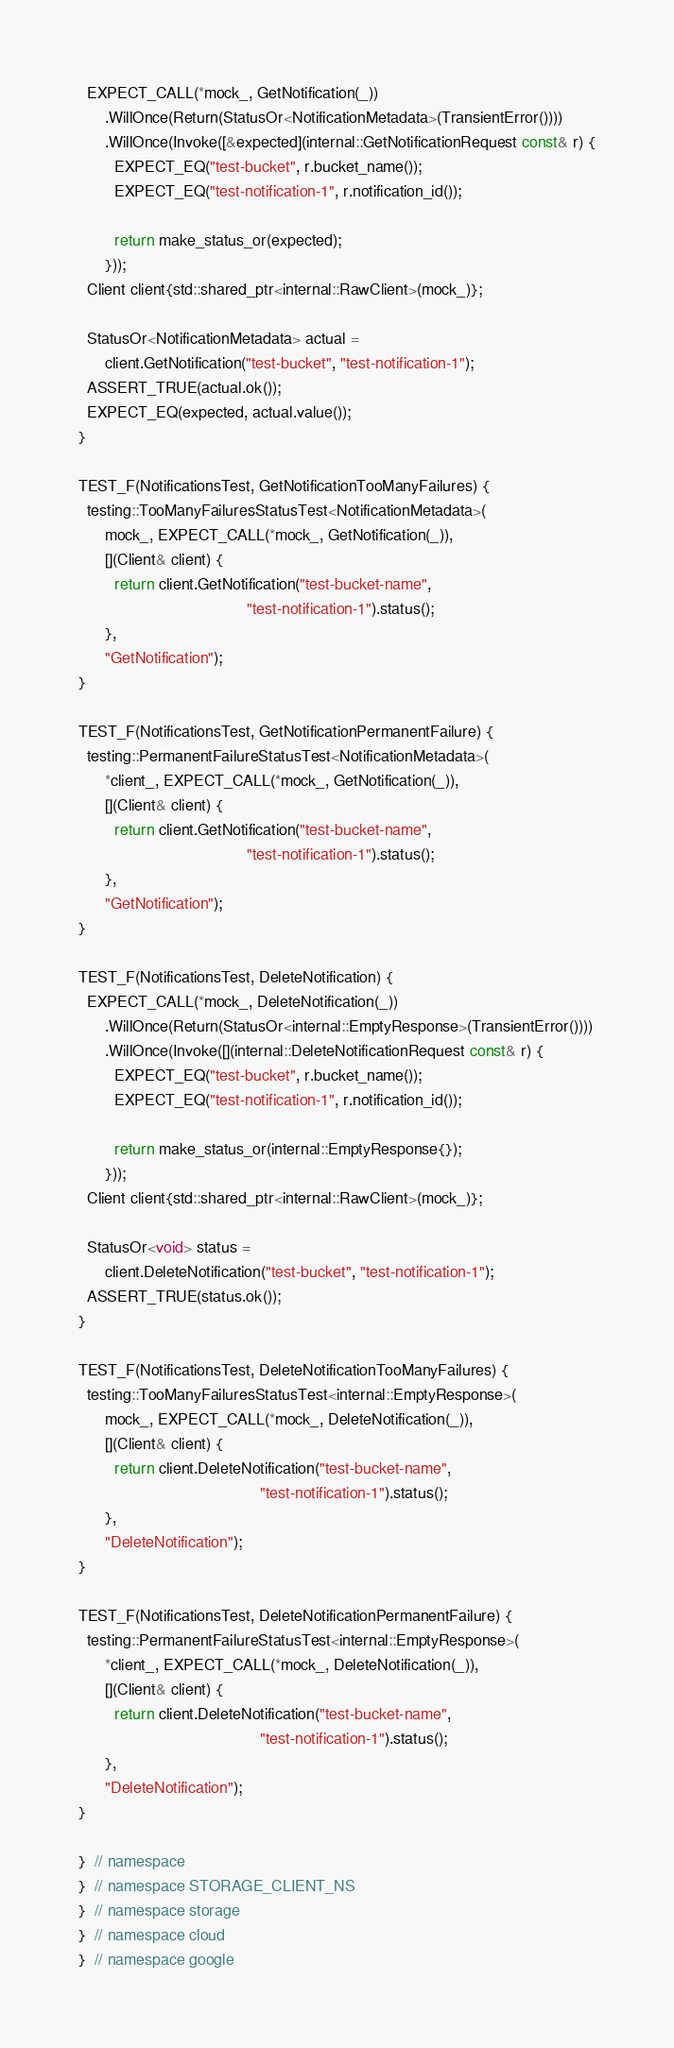<code> <loc_0><loc_0><loc_500><loc_500><_C++_>
  EXPECT_CALL(*mock_, GetNotification(_))
      .WillOnce(Return(StatusOr<NotificationMetadata>(TransientError())))
      .WillOnce(Invoke([&expected](internal::GetNotificationRequest const& r) {
        EXPECT_EQ("test-bucket", r.bucket_name());
        EXPECT_EQ("test-notification-1", r.notification_id());

        return make_status_or(expected);
      }));
  Client client{std::shared_ptr<internal::RawClient>(mock_)};

  StatusOr<NotificationMetadata> actual =
      client.GetNotification("test-bucket", "test-notification-1");
  ASSERT_TRUE(actual.ok());
  EXPECT_EQ(expected, actual.value());
}

TEST_F(NotificationsTest, GetNotificationTooManyFailures) {
  testing::TooManyFailuresStatusTest<NotificationMetadata>(
      mock_, EXPECT_CALL(*mock_, GetNotification(_)),
      [](Client& client) {
        return client.GetNotification("test-bucket-name",
                                      "test-notification-1").status();
      },
      "GetNotification");
}

TEST_F(NotificationsTest, GetNotificationPermanentFailure) {
  testing::PermanentFailureStatusTest<NotificationMetadata>(
      *client_, EXPECT_CALL(*mock_, GetNotification(_)),
      [](Client& client) {
        return client.GetNotification("test-bucket-name",
                                      "test-notification-1").status();
      },
      "GetNotification");
}

TEST_F(NotificationsTest, DeleteNotification) {
  EXPECT_CALL(*mock_, DeleteNotification(_))
      .WillOnce(Return(StatusOr<internal::EmptyResponse>(TransientError())))
      .WillOnce(Invoke([](internal::DeleteNotificationRequest const& r) {
        EXPECT_EQ("test-bucket", r.bucket_name());
        EXPECT_EQ("test-notification-1", r.notification_id());

        return make_status_or(internal::EmptyResponse{});
      }));
  Client client{std::shared_ptr<internal::RawClient>(mock_)};

  StatusOr<void> status =
      client.DeleteNotification("test-bucket", "test-notification-1");
  ASSERT_TRUE(status.ok());
}

TEST_F(NotificationsTest, DeleteNotificationTooManyFailures) {
  testing::TooManyFailuresStatusTest<internal::EmptyResponse>(
      mock_, EXPECT_CALL(*mock_, DeleteNotification(_)),
      [](Client& client) {
        return client.DeleteNotification("test-bucket-name",
                                         "test-notification-1").status();
      },
      "DeleteNotification");
}

TEST_F(NotificationsTest, DeleteNotificationPermanentFailure) {
  testing::PermanentFailureStatusTest<internal::EmptyResponse>(
      *client_, EXPECT_CALL(*mock_, DeleteNotification(_)),
      [](Client& client) {
        return client.DeleteNotification("test-bucket-name",
                                         "test-notification-1").status();
      },
      "DeleteNotification");
}

}  // namespace
}  // namespace STORAGE_CLIENT_NS
}  // namespace storage
}  // namespace cloud
}  // namespace google
</code> 